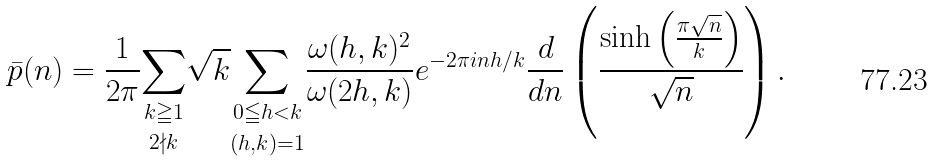<formula> <loc_0><loc_0><loc_500><loc_500>\bar { p } ( n ) = \frac { 1 } { 2 \pi } \underset { 2 \nmid k } { \sum _ { k \geqq 1 } } \sqrt { k } \underset { ( h , k ) = 1 } { \sum _ { 0 \leqq h < k } } \frac { \omega ( h , k ) ^ { 2 } } { \omega ( 2 h , k ) } e ^ { - 2 \pi i n h / k } \frac { d } { d n } \left ( \frac { \sinh \left ( \frac { \pi \sqrt { n } } { k } \right ) } { \sqrt { n } } \right ) .</formula> 